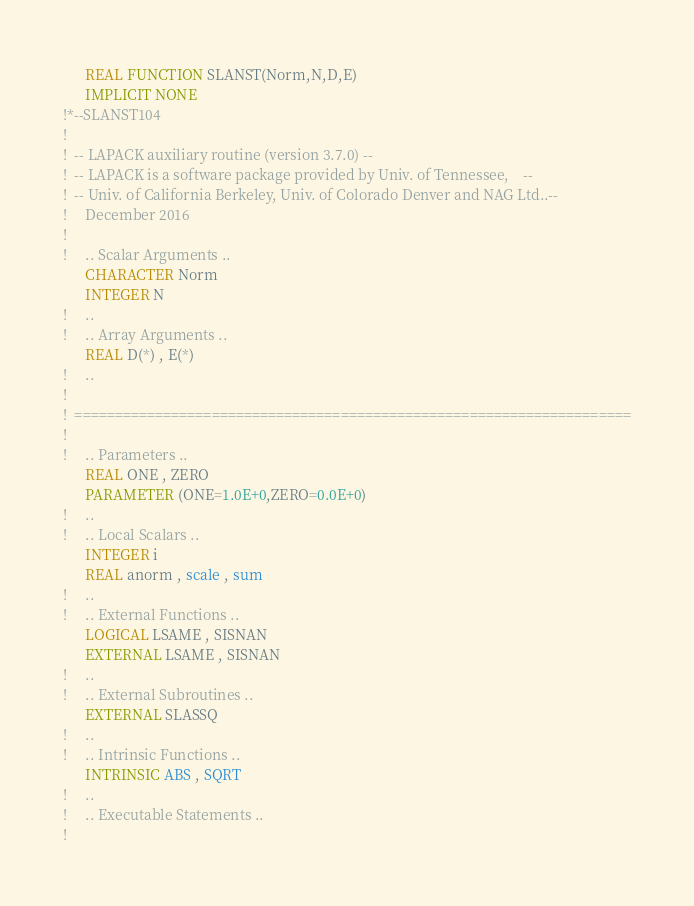Convert code to text. <code><loc_0><loc_0><loc_500><loc_500><_FORTRAN_>      REAL FUNCTION SLANST(Norm,N,D,E)
      IMPLICIT NONE
!*--SLANST104
!
!  -- LAPACK auxiliary routine (version 3.7.0) --
!  -- LAPACK is a software package provided by Univ. of Tennessee,    --
!  -- Univ. of California Berkeley, Univ. of Colorado Denver and NAG Ltd..--
!     December 2016
!
!     .. Scalar Arguments ..
      CHARACTER Norm
      INTEGER N
!     ..
!     .. Array Arguments ..
      REAL D(*) , E(*)
!     ..
!
!  =====================================================================
!
!     .. Parameters ..
      REAL ONE , ZERO
      PARAMETER (ONE=1.0E+0,ZERO=0.0E+0)
!     ..
!     .. Local Scalars ..
      INTEGER i
      REAL anorm , scale , sum
!     ..
!     .. External Functions ..
      LOGICAL LSAME , SISNAN
      EXTERNAL LSAME , SISNAN
!     ..
!     .. External Subroutines ..
      EXTERNAL SLASSQ
!     ..
!     .. Intrinsic Functions ..
      INTRINSIC ABS , SQRT
!     ..
!     .. Executable Statements ..
!</code> 